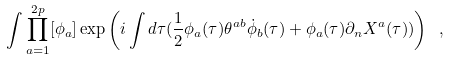Convert formula to latex. <formula><loc_0><loc_0><loc_500><loc_500>\int \prod _ { a = 1 } ^ { 2 p } [ \phi _ { a } ] \exp \left ( i \int d \tau ( \frac { 1 } { 2 } \phi _ { a } ( \tau ) \theta ^ { a b } \dot { \phi } _ { b } ( \tau ) + \phi _ { a } ( \tau ) \partial _ { n } X ^ { a } ( \tau ) ) \right ) \ ,</formula> 